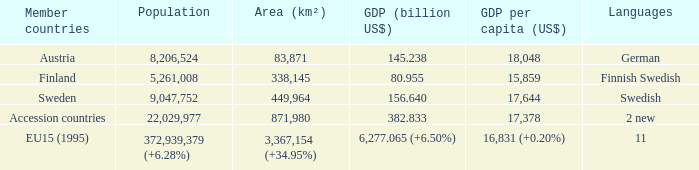Determine the population for 11 linguistic groups 372,939,379 (+6.28%). 